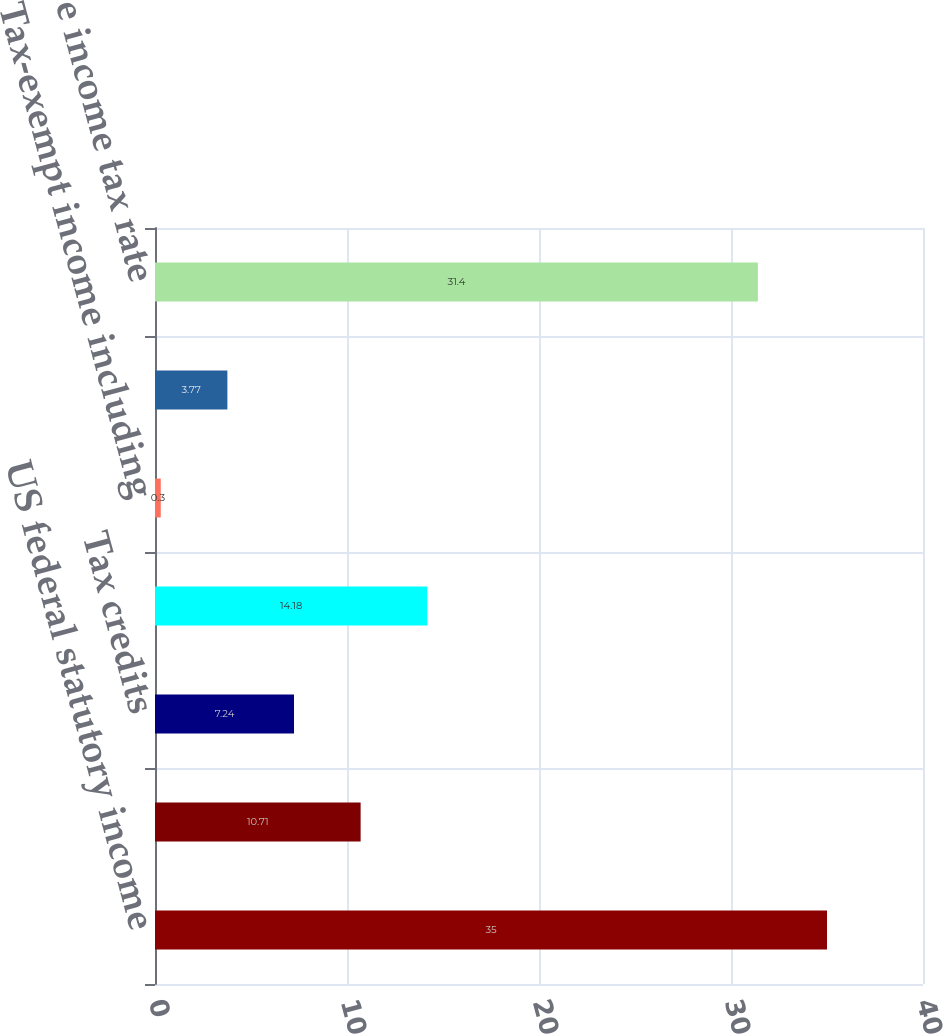Convert chart. <chart><loc_0><loc_0><loc_500><loc_500><bar_chart><fcel>US federal statutory income<fcel>State and local taxes net of<fcel>Tax credits<fcel>Non-US operations 1<fcel>Tax-exempt income including<fcel>Other<fcel>Effective income tax rate<nl><fcel>35<fcel>10.71<fcel>7.24<fcel>14.18<fcel>0.3<fcel>3.77<fcel>31.4<nl></chart> 